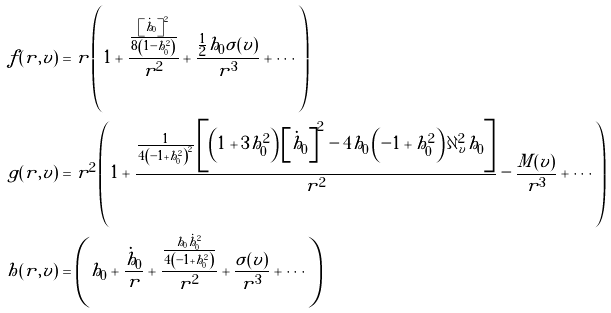<formula> <loc_0><loc_0><loc_500><loc_500>f ( r , v ) & = r \left ( 1 + \frac { \frac { \left [ { \dot { h } } _ { 0 } \right ] ^ { 2 } } { 8 \left ( 1 - h _ { 0 } ^ { 2 } \right ) } } { r ^ { 2 } } + \frac { \frac { 1 } { 2 } h _ { 0 } \sigma ( v ) } { r ^ { 3 } } + \cdots \right ) \\ g ( r , v ) & = r ^ { 2 } \left ( 1 + \frac { \frac { 1 } { 4 \left ( - 1 + h _ { 0 } ^ { 2 } \right ) ^ { 2 } } \left [ { \left ( 1 + 3 h _ { 0 } ^ { 2 } \right ) } \left [ { \dot { h } } _ { 0 } \right ] ^ { 2 } - 4 h _ { 0 } \left ( - 1 + h _ { 0 } ^ { 2 } \right ) \partial _ { v } ^ { 2 } h _ { 0 } \right ] } { r ^ { 2 } } - \frac { M ( v ) } { r ^ { 3 } } + \cdots \right ) \\ h ( r , v ) & = \left ( h _ { 0 } + \frac { \dot { h } _ { 0 } } { r } + \frac { \frac { h _ { 0 } { \dot { h } _ { 0 } } ^ { 2 } } { 4 \left ( - 1 + h _ { 0 } ^ { 2 } \right ) } } { r ^ { 2 } } + \frac { \sigma ( v ) } { r ^ { 3 } } + \cdots \right ) \\</formula> 